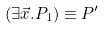<formula> <loc_0><loc_0><loc_500><loc_500>( \exists \vec { x } . P _ { 1 } ) \equiv P ^ { \prime }</formula> 